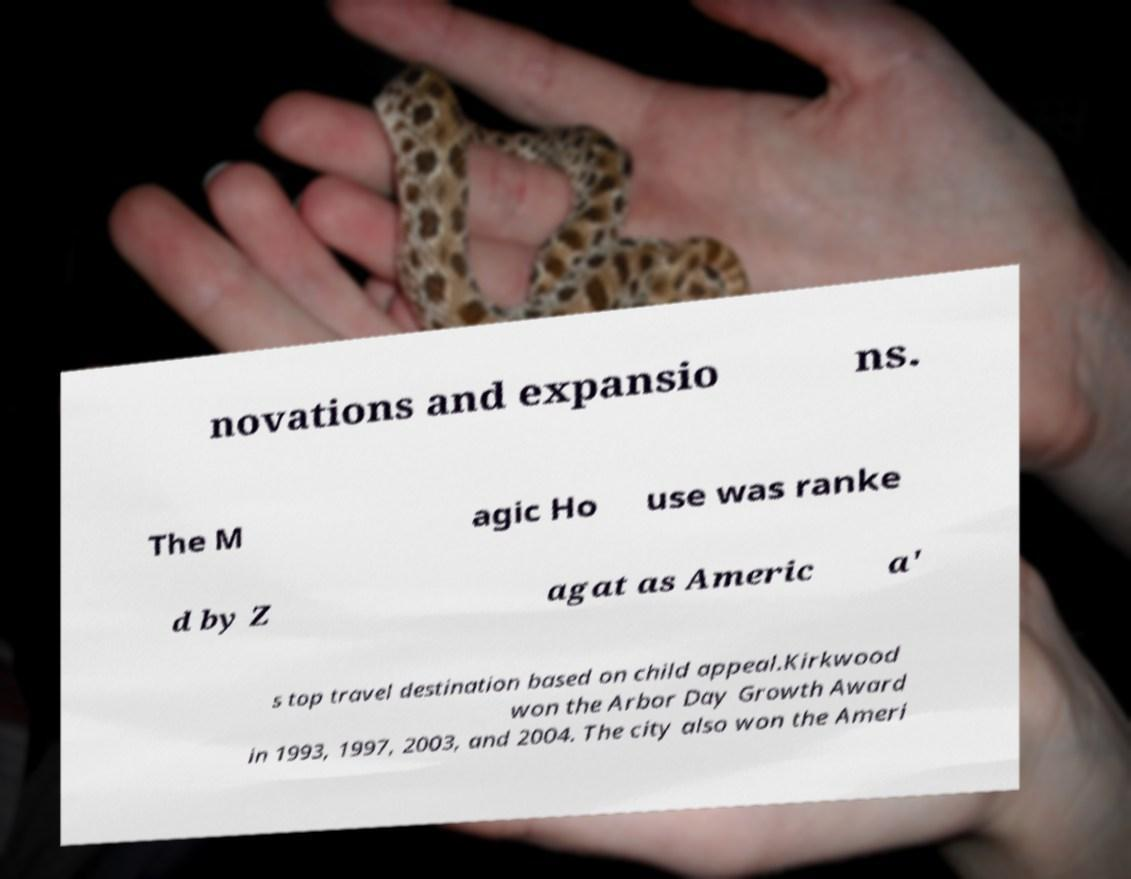What messages or text are displayed in this image? I need them in a readable, typed format. novations and expansio ns. The M agic Ho use was ranke d by Z agat as Americ a' s top travel destination based on child appeal.Kirkwood won the Arbor Day Growth Award in 1993, 1997, 2003, and 2004. The city also won the Ameri 